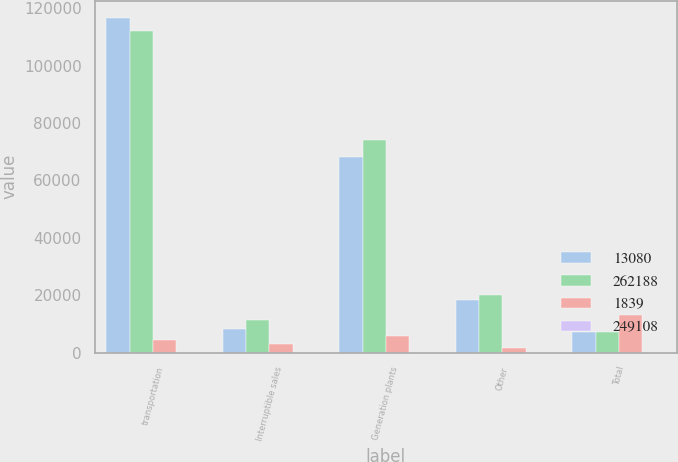Convert chart. <chart><loc_0><loc_0><loc_500><loc_500><stacked_bar_chart><ecel><fcel>transportation<fcel>Interruptible sales<fcel>Generation plants<fcel>Other<fcel>Total<nl><fcel>13080<fcel>116665<fcel>8225<fcel>68157<fcel>18297<fcel>7075<nl><fcel>262188<fcel>112188<fcel>11220<fcel>74082<fcel>20004<fcel>7075<nl><fcel>1839<fcel>4477<fcel>2995<fcel>5925<fcel>1707<fcel>13080<nl><fcel>249108<fcel>4<fcel>26.7<fcel>8<fcel>8.5<fcel>5<nl></chart> 